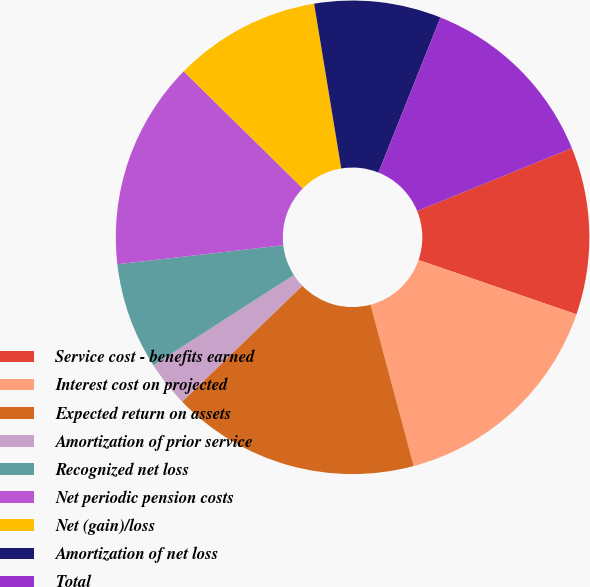Convert chart. <chart><loc_0><loc_0><loc_500><loc_500><pie_chart><fcel>Service cost - benefits earned<fcel>Interest cost on projected<fcel>Expected return on assets<fcel>Amortization of prior service<fcel>Recognized net loss<fcel>Net periodic pension costs<fcel>Net (gain)/loss<fcel>Amortization of net loss<fcel>Total<nl><fcel>11.42%<fcel>15.57%<fcel>16.95%<fcel>3.12%<fcel>7.27%<fcel>14.18%<fcel>10.04%<fcel>8.65%<fcel>12.8%<nl></chart> 